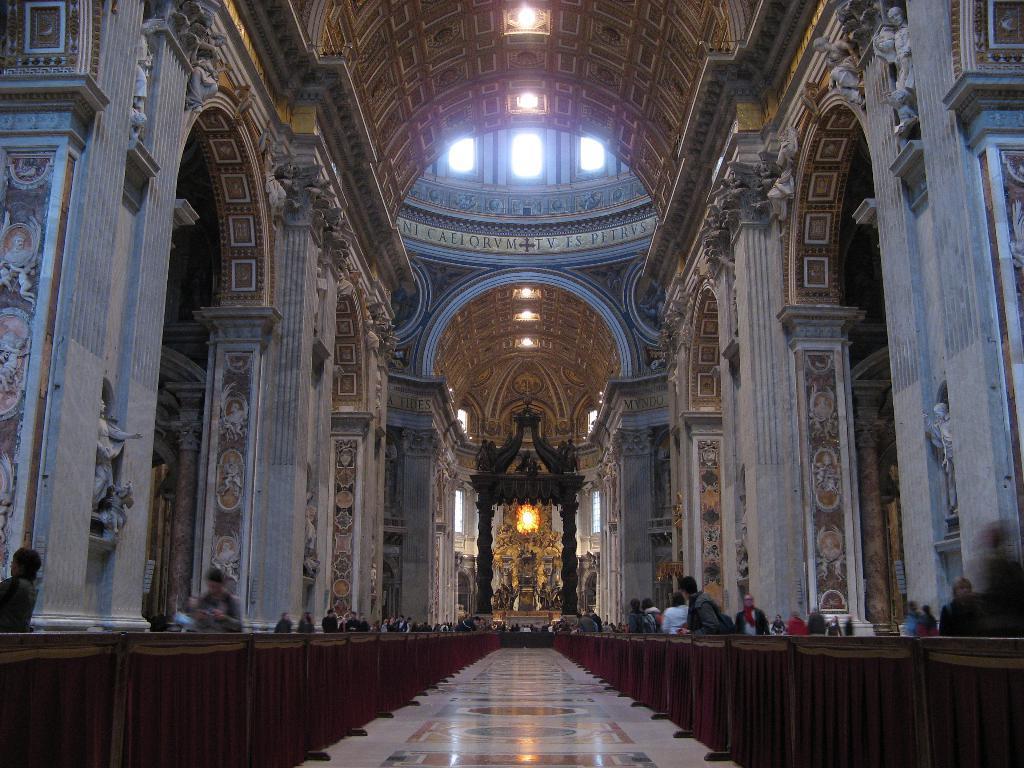How would you summarize this image in a sentence or two? In this image we can see few persons on the left and right side. There are designs on the floor, lights on the ceiling, objects, statues and pillars. In the background we can see few persons, arch, designs on the wall and objects. 